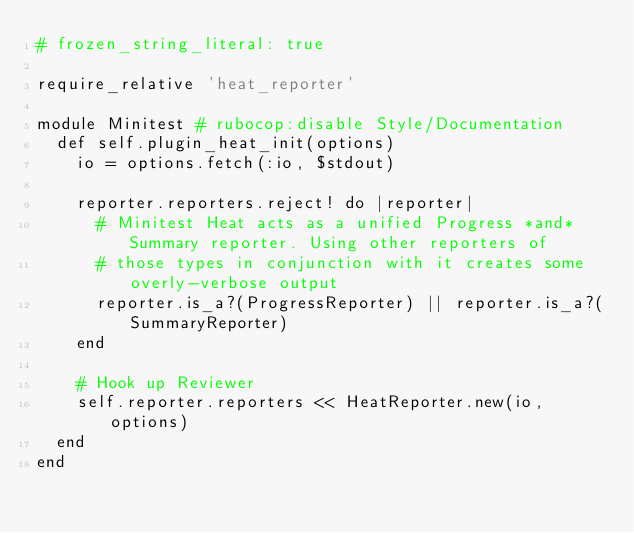<code> <loc_0><loc_0><loc_500><loc_500><_Ruby_># frozen_string_literal: true

require_relative 'heat_reporter'

module Minitest # rubocop:disable Style/Documentation
  def self.plugin_heat_init(options)
    io = options.fetch(:io, $stdout)

    reporter.reporters.reject! do |reporter|
      # Minitest Heat acts as a unified Progress *and* Summary reporter. Using other reporters of
      # those types in conjunction with it creates some overly-verbose output
      reporter.is_a?(ProgressReporter) || reporter.is_a?(SummaryReporter)
    end

    # Hook up Reviewer
    self.reporter.reporters << HeatReporter.new(io, options)
  end
end
</code> 